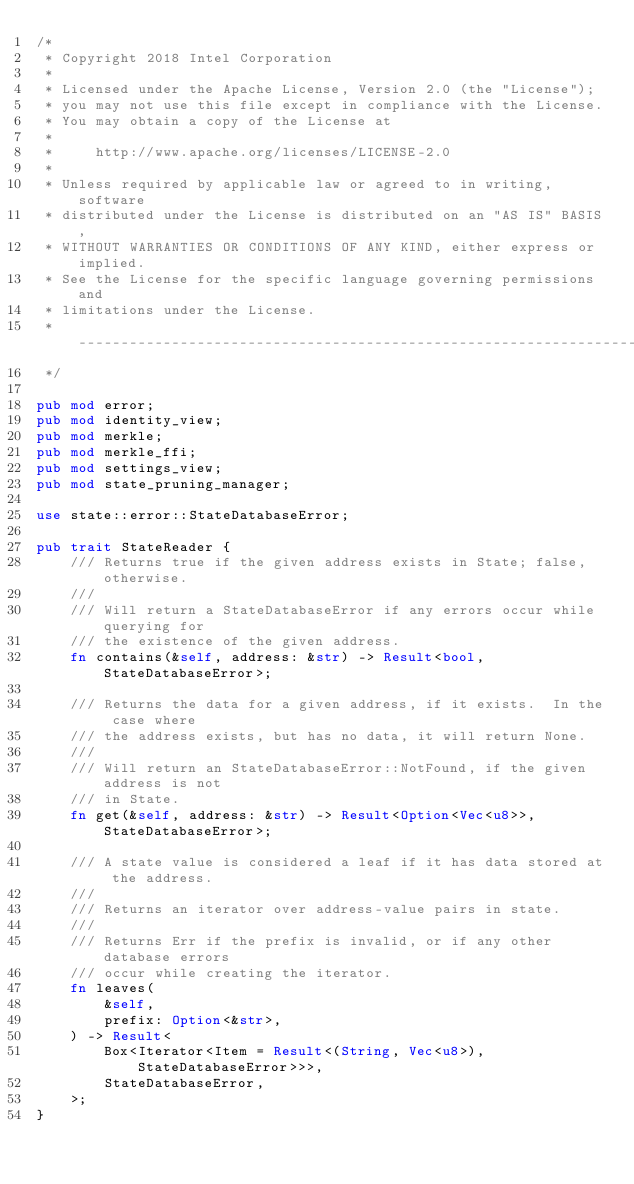Convert code to text. <code><loc_0><loc_0><loc_500><loc_500><_Rust_>/*
 * Copyright 2018 Intel Corporation
 *
 * Licensed under the Apache License, Version 2.0 (the "License");
 * you may not use this file except in compliance with the License.
 * You may obtain a copy of the License at
 *
 *     http://www.apache.org/licenses/LICENSE-2.0
 *
 * Unless required by applicable law or agreed to in writing, software
 * distributed under the License is distributed on an "AS IS" BASIS,
 * WITHOUT WARRANTIES OR CONDITIONS OF ANY KIND, either express or implied.
 * See the License for the specific language governing permissions and
 * limitations under the License.
 * ------------------------------------------------------------------------------
 */

pub mod error;
pub mod identity_view;
pub mod merkle;
pub mod merkle_ffi;
pub mod settings_view;
pub mod state_pruning_manager;

use state::error::StateDatabaseError;

pub trait StateReader {
    /// Returns true if the given address exists in State; false, otherwise.
    ///
    /// Will return a StateDatabaseError if any errors occur while querying for
    /// the existence of the given address.
    fn contains(&self, address: &str) -> Result<bool, StateDatabaseError>;

    /// Returns the data for a given address, if it exists.  In the case where
    /// the address exists, but has no data, it will return None.
    ///
    /// Will return an StateDatabaseError::NotFound, if the given address is not
    /// in State.
    fn get(&self, address: &str) -> Result<Option<Vec<u8>>, StateDatabaseError>;

    /// A state value is considered a leaf if it has data stored at the address.
    ///
    /// Returns an iterator over address-value pairs in state.
    ///
    /// Returns Err if the prefix is invalid, or if any other database errors
    /// occur while creating the iterator.
    fn leaves(
        &self,
        prefix: Option<&str>,
    ) -> Result<
        Box<Iterator<Item = Result<(String, Vec<u8>), StateDatabaseError>>>,
        StateDatabaseError,
    >;
}
</code> 